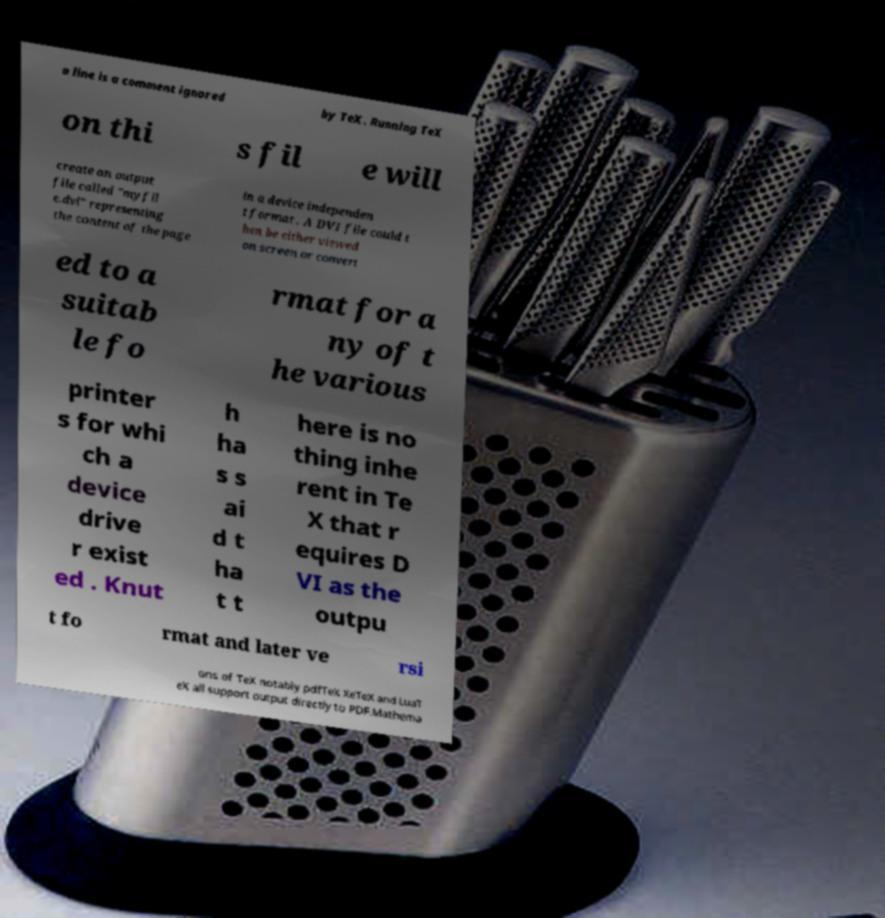Please identify and transcribe the text found in this image. a line is a comment ignored by TeX. Running TeX on thi s fil e will create an output file called "myfil e.dvi" representing the content of the page in a device independen t format . A DVI file could t hen be either viewed on screen or convert ed to a suitab le fo rmat for a ny of t he various printer s for whi ch a device drive r exist ed . Knut h ha s s ai d t ha t t here is no thing inhe rent in Te X that r equires D VI as the outpu t fo rmat and later ve rsi ons of TeX notably pdfTeX XeTeX and LuaT eX all support output directly to PDF.Mathema 